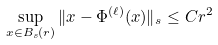<formula> <loc_0><loc_0><loc_500><loc_500>\sup _ { x \in B _ { s } ( r ) } \| x - \Phi ^ { ( \ell ) } ( x ) \| _ { s } \leq C r ^ { 2 }</formula> 